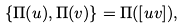<formula> <loc_0><loc_0><loc_500><loc_500>\{ \Pi ( u ) , \Pi ( v ) \} = \Pi ( [ u v ] ) ,</formula> 